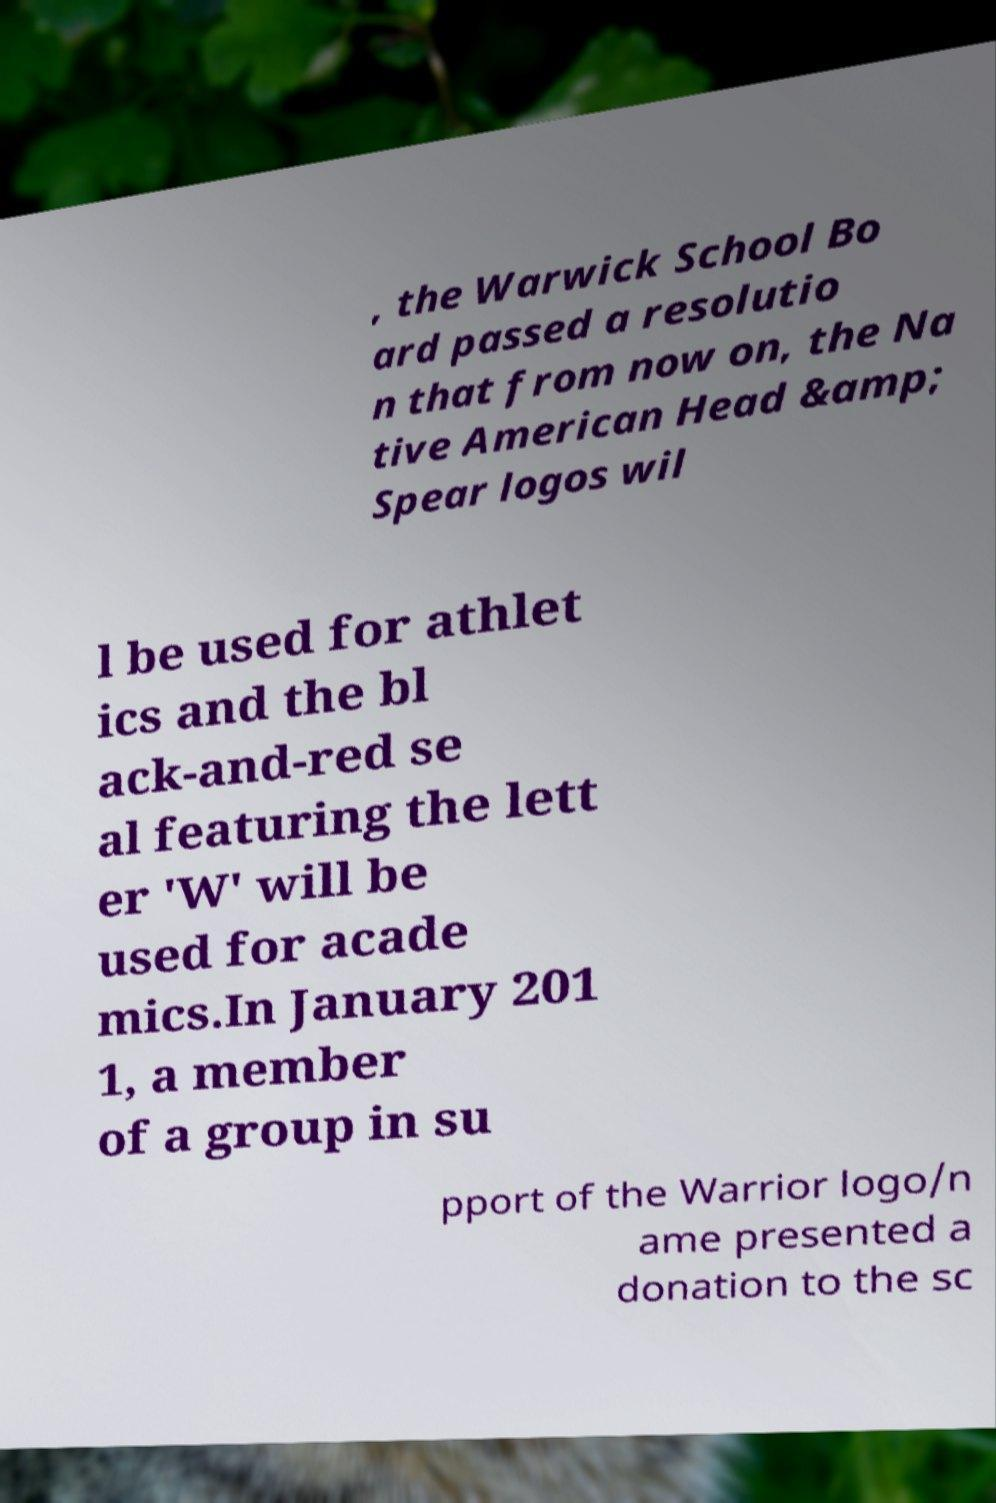What messages or text are displayed in this image? I need them in a readable, typed format. , the Warwick School Bo ard passed a resolutio n that from now on, the Na tive American Head &amp; Spear logos wil l be used for athlet ics and the bl ack-and-red se al featuring the lett er 'W' will be used for acade mics.In January 201 1, a member of a group in su pport of the Warrior logo/n ame presented a donation to the sc 